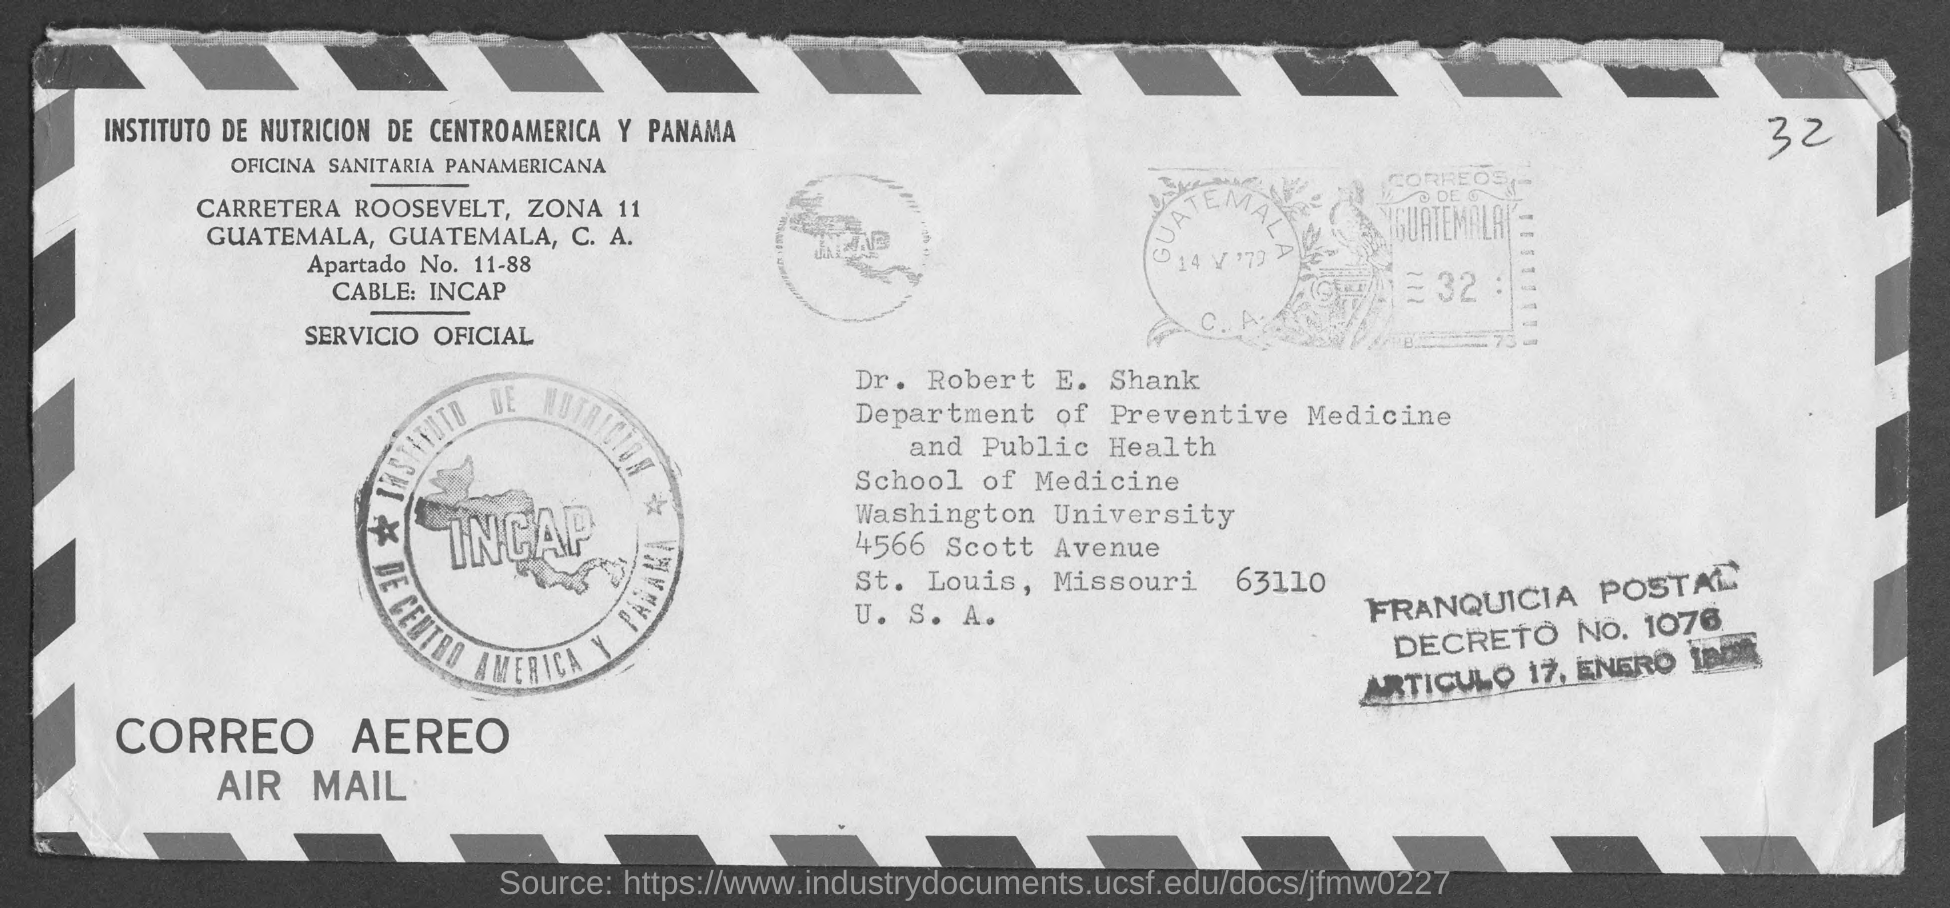Specify some key components in this picture. Dr. Robert E. Shank belongs to the Department of Preventive Medicine and Public Health. Washington University is located in the state of Missouri and the city of St. Louis. Washington University is located in the United States of America. This post is addressed to Dr. Robert E. Shank. Dr. Robert E Shank is a member of Washington University. 